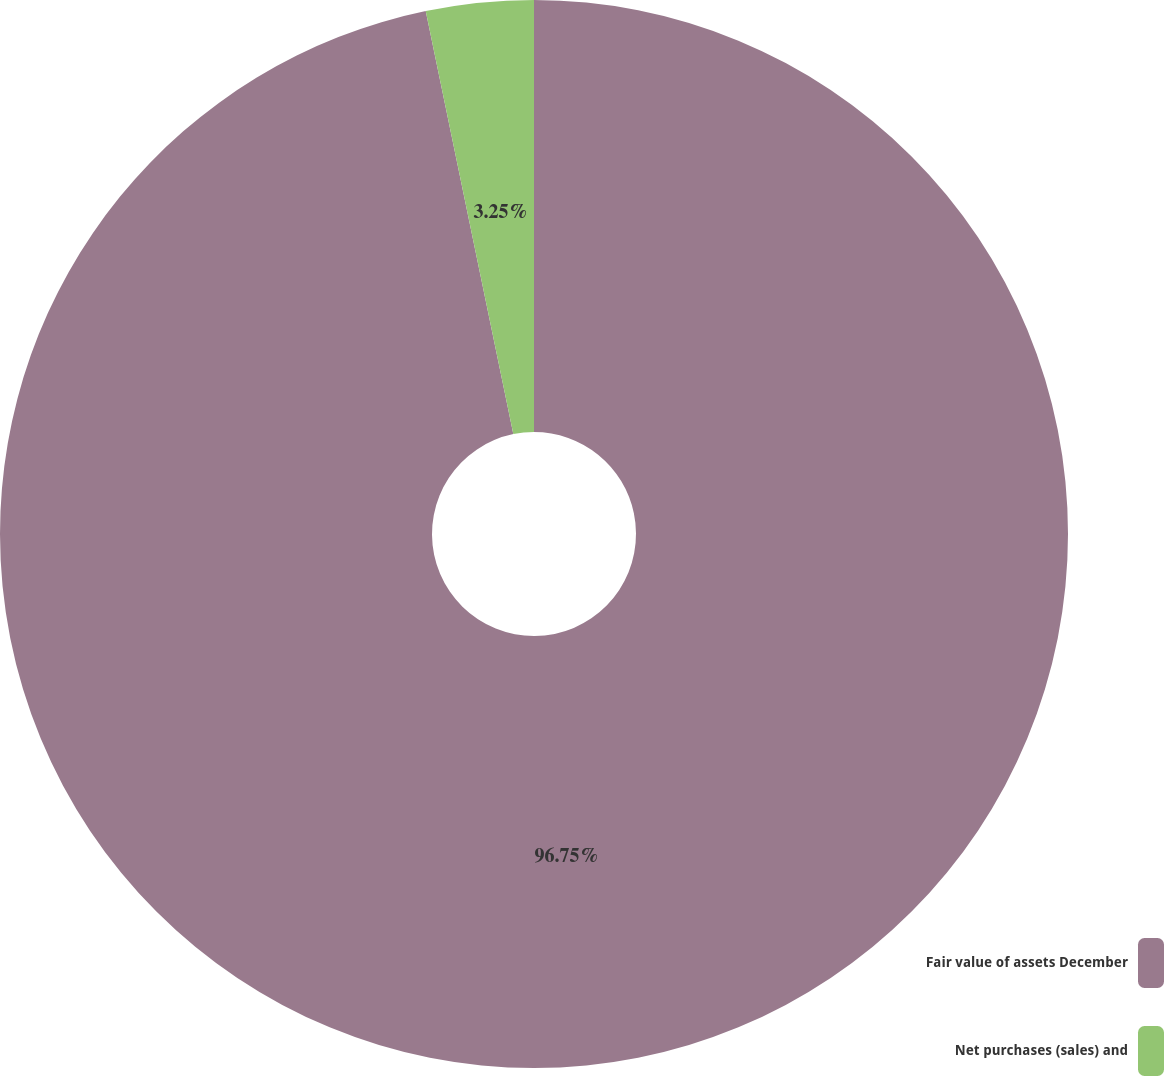Convert chart. <chart><loc_0><loc_0><loc_500><loc_500><pie_chart><fcel>Fair value of assets December<fcel>Net purchases (sales) and<nl><fcel>96.75%<fcel>3.25%<nl></chart> 